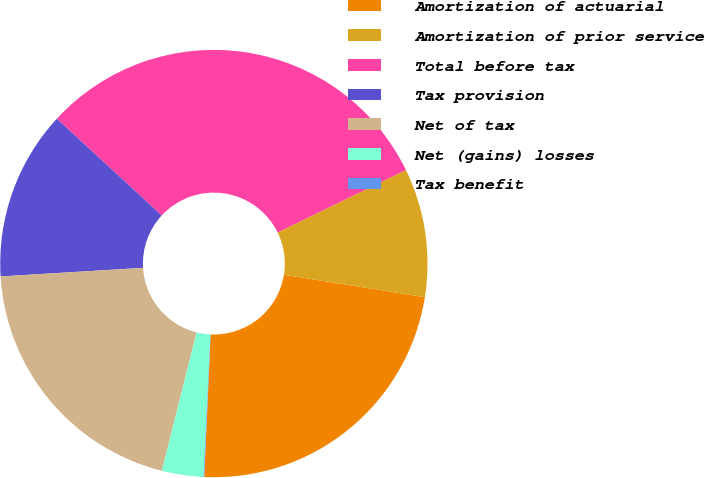Convert chart to OTSL. <chart><loc_0><loc_0><loc_500><loc_500><pie_chart><fcel>Amortization of actuarial<fcel>Amortization of prior service<fcel>Total before tax<fcel>Tax provision<fcel>Net of tax<fcel>Net (gains) losses<fcel>Tax benefit<nl><fcel>23.21%<fcel>9.73%<fcel>30.93%<fcel>12.82%<fcel>20.13%<fcel>3.14%<fcel>0.05%<nl></chart> 